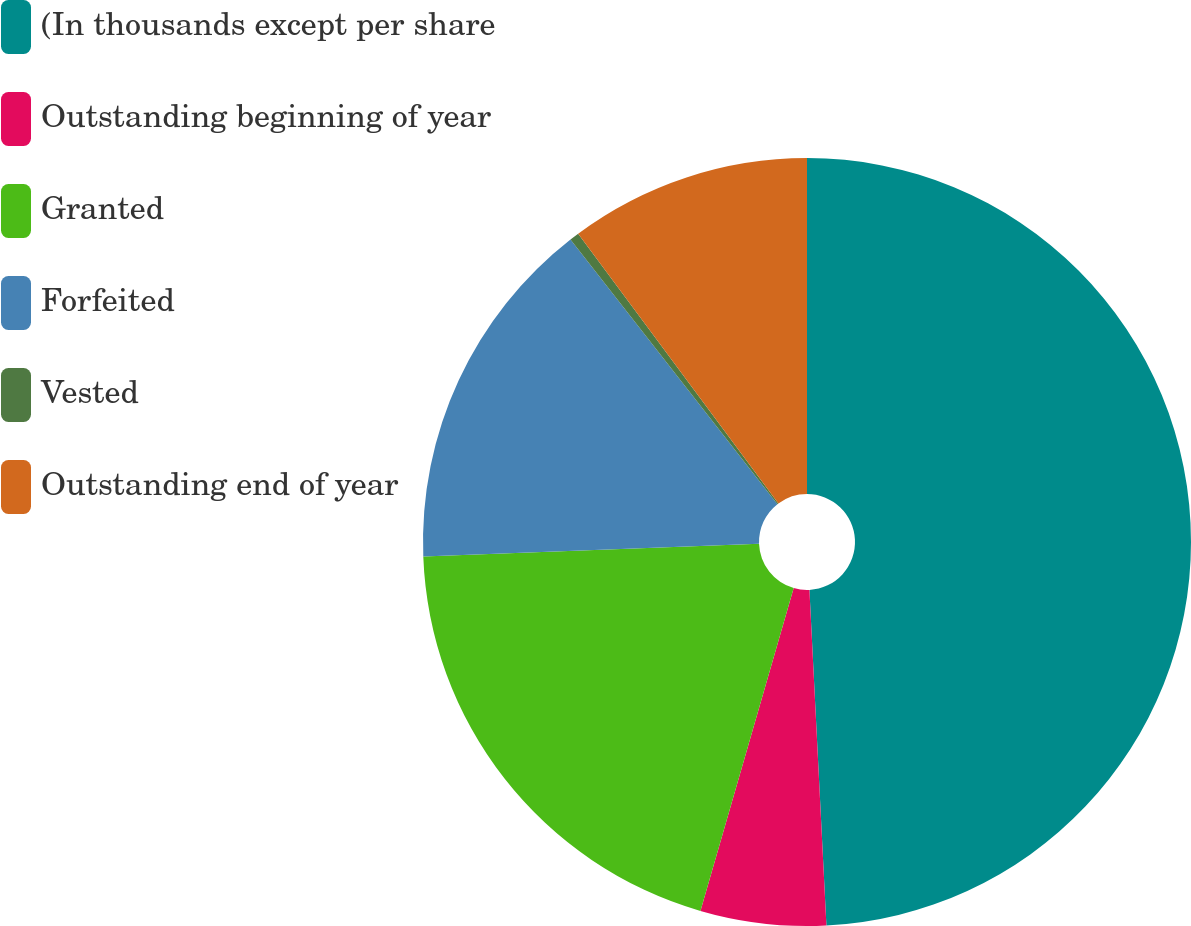Convert chart. <chart><loc_0><loc_0><loc_500><loc_500><pie_chart><fcel>(In thousands except per share<fcel>Outstanding beginning of year<fcel>Granted<fcel>Forfeited<fcel>Vested<fcel>Outstanding end of year<nl><fcel>49.19%<fcel>5.28%<fcel>19.92%<fcel>15.04%<fcel>0.4%<fcel>10.16%<nl></chart> 